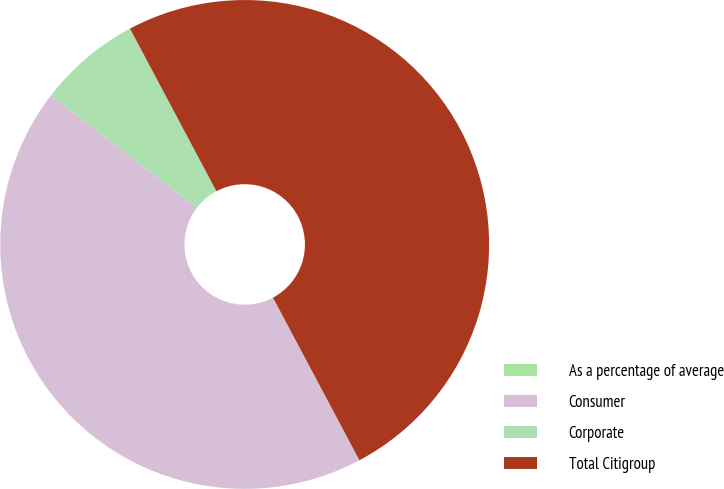Convert chart to OTSL. <chart><loc_0><loc_0><loc_500><loc_500><pie_chart><fcel>As a percentage of average<fcel>Consumer<fcel>Corporate<fcel>Total Citigroup<nl><fcel>0.0%<fcel>43.2%<fcel>6.8%<fcel>50.0%<nl></chart> 